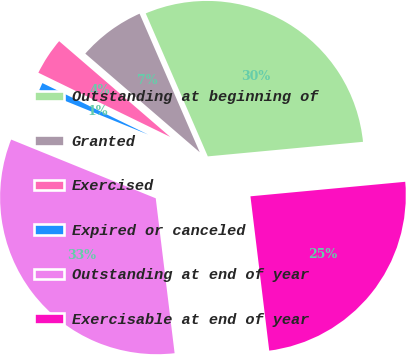Convert chart to OTSL. <chart><loc_0><loc_0><loc_500><loc_500><pie_chart><fcel>Outstanding at beginning of<fcel>Granted<fcel>Exercised<fcel>Expired or canceled<fcel>Outstanding at end of year<fcel>Exercisable at end of year<nl><fcel>30.03%<fcel>7.16%<fcel>4.11%<fcel>1.07%<fcel>33.07%<fcel>24.56%<nl></chart> 